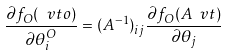Convert formula to latex. <formula><loc_0><loc_0><loc_500><loc_500>\frac { \partial f _ { O } ( \ v t o ) } { \partial \theta ^ { O } _ { i } } = ( A ^ { - 1 } ) _ { i j } \frac { \partial f _ { O } ( A \ v t ) } { \partial \theta _ { j } }</formula> 